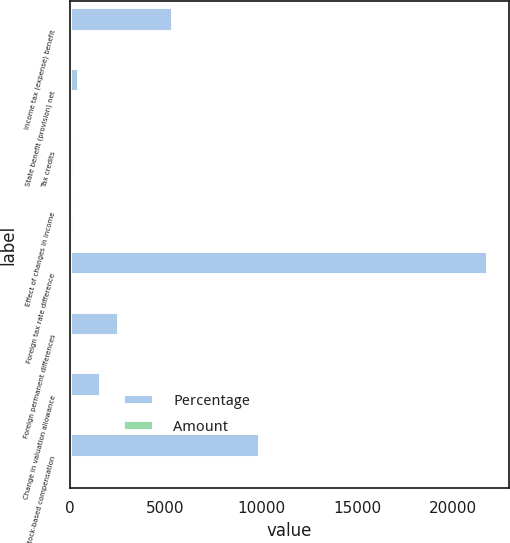Convert chart. <chart><loc_0><loc_0><loc_500><loc_500><stacked_bar_chart><ecel><fcel>Income tax (expense) benefit<fcel>State benefit (provision) net<fcel>Tax credits<fcel>Effect of changes in income<fcel>Foreign tax rate difference<fcel>Foreign permanent differences<fcel>Change in valuation allowance<fcel>Stock-based compensation<nl><fcel>Percentage<fcel>5407<fcel>474<fcel>225.2<fcel>225.2<fcel>21829<fcel>2598<fcel>1632<fcel>9924<nl><fcel>Amount<fcel>31.54<fcel>2.77<fcel>221.95<fcel>228.45<fcel>127.32<fcel>15.15<fcel>9.52<fcel>57.88<nl></chart> 